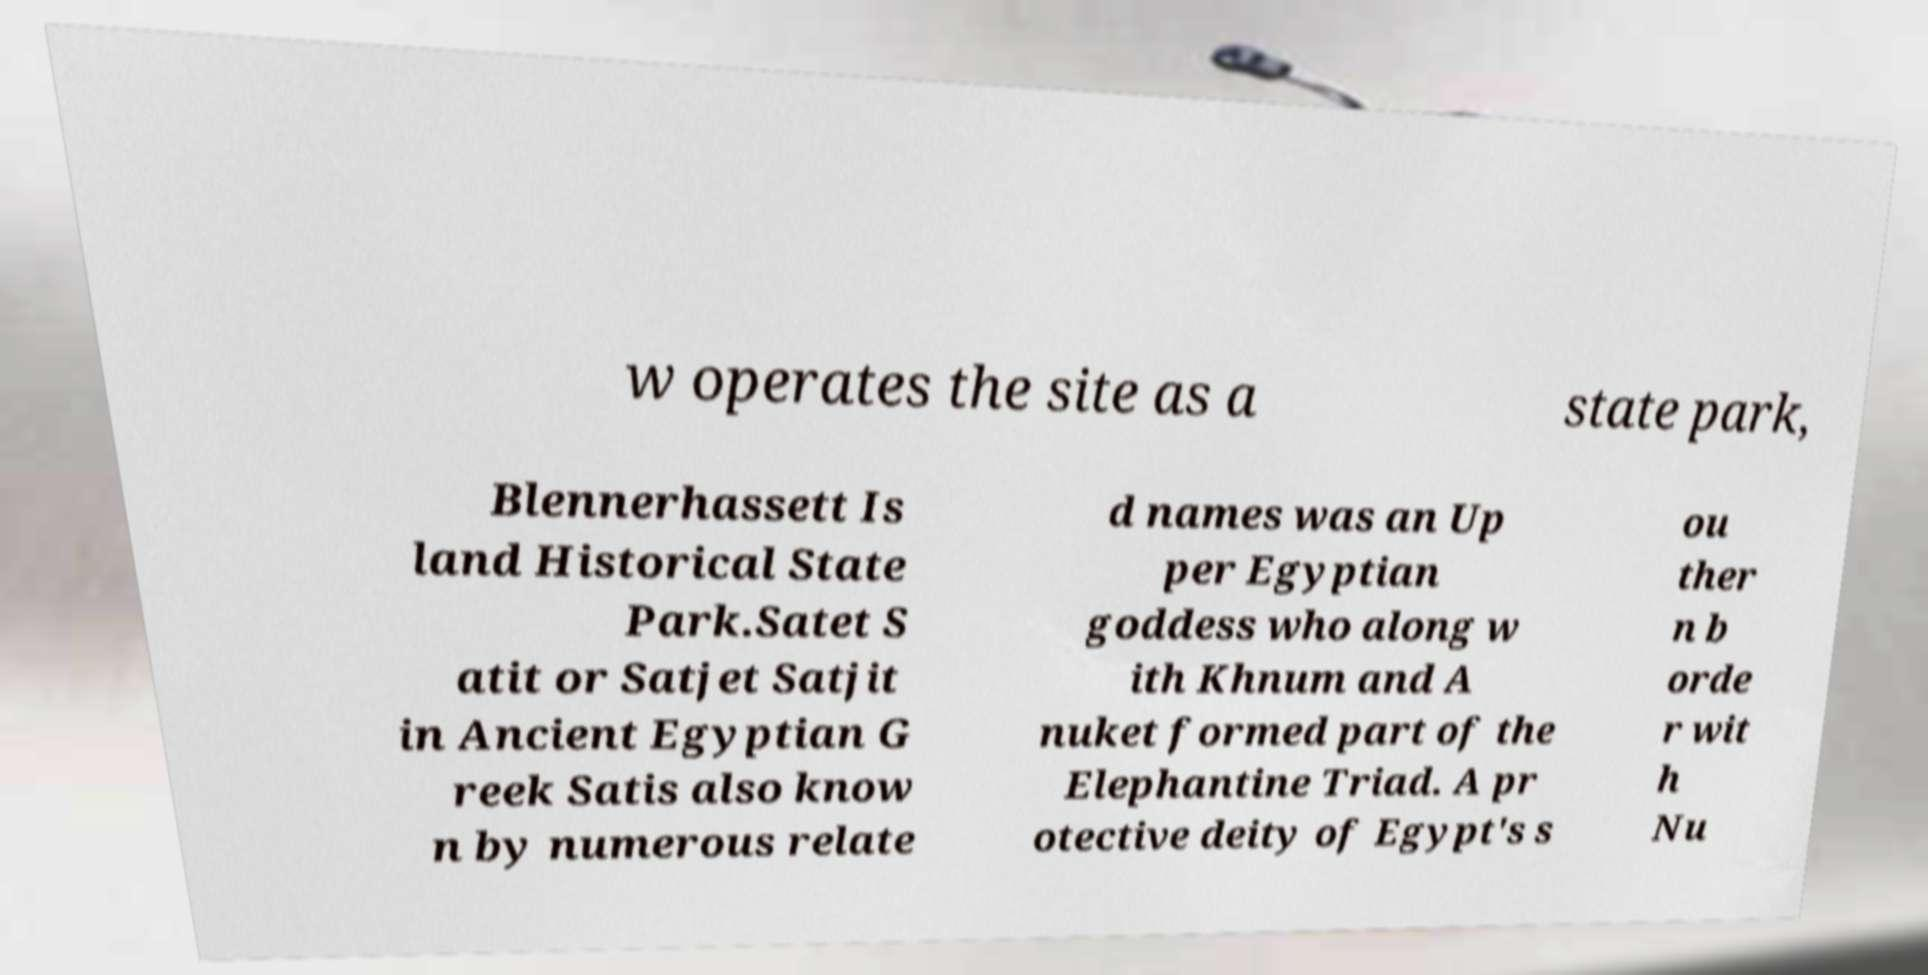Can you read and provide the text displayed in the image?This photo seems to have some interesting text. Can you extract and type it out for me? w operates the site as a state park, Blennerhassett Is land Historical State Park.Satet S atit or Satjet Satjit in Ancient Egyptian G reek Satis also know n by numerous relate d names was an Up per Egyptian goddess who along w ith Khnum and A nuket formed part of the Elephantine Triad. A pr otective deity of Egypt's s ou ther n b orde r wit h Nu 